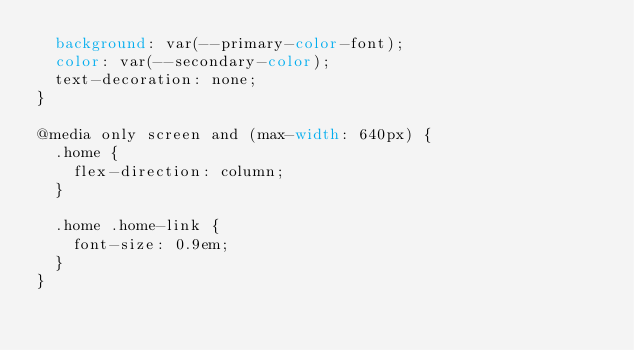<code> <loc_0><loc_0><loc_500><loc_500><_CSS_>  background: var(--primary-color-font);
  color: var(--secondary-color);
  text-decoration: none;
}

@media only screen and (max-width: 640px) {
  .home {
    flex-direction: column;
  }

  .home .home-link {
    font-size: 0.9em;
  }
}
</code> 